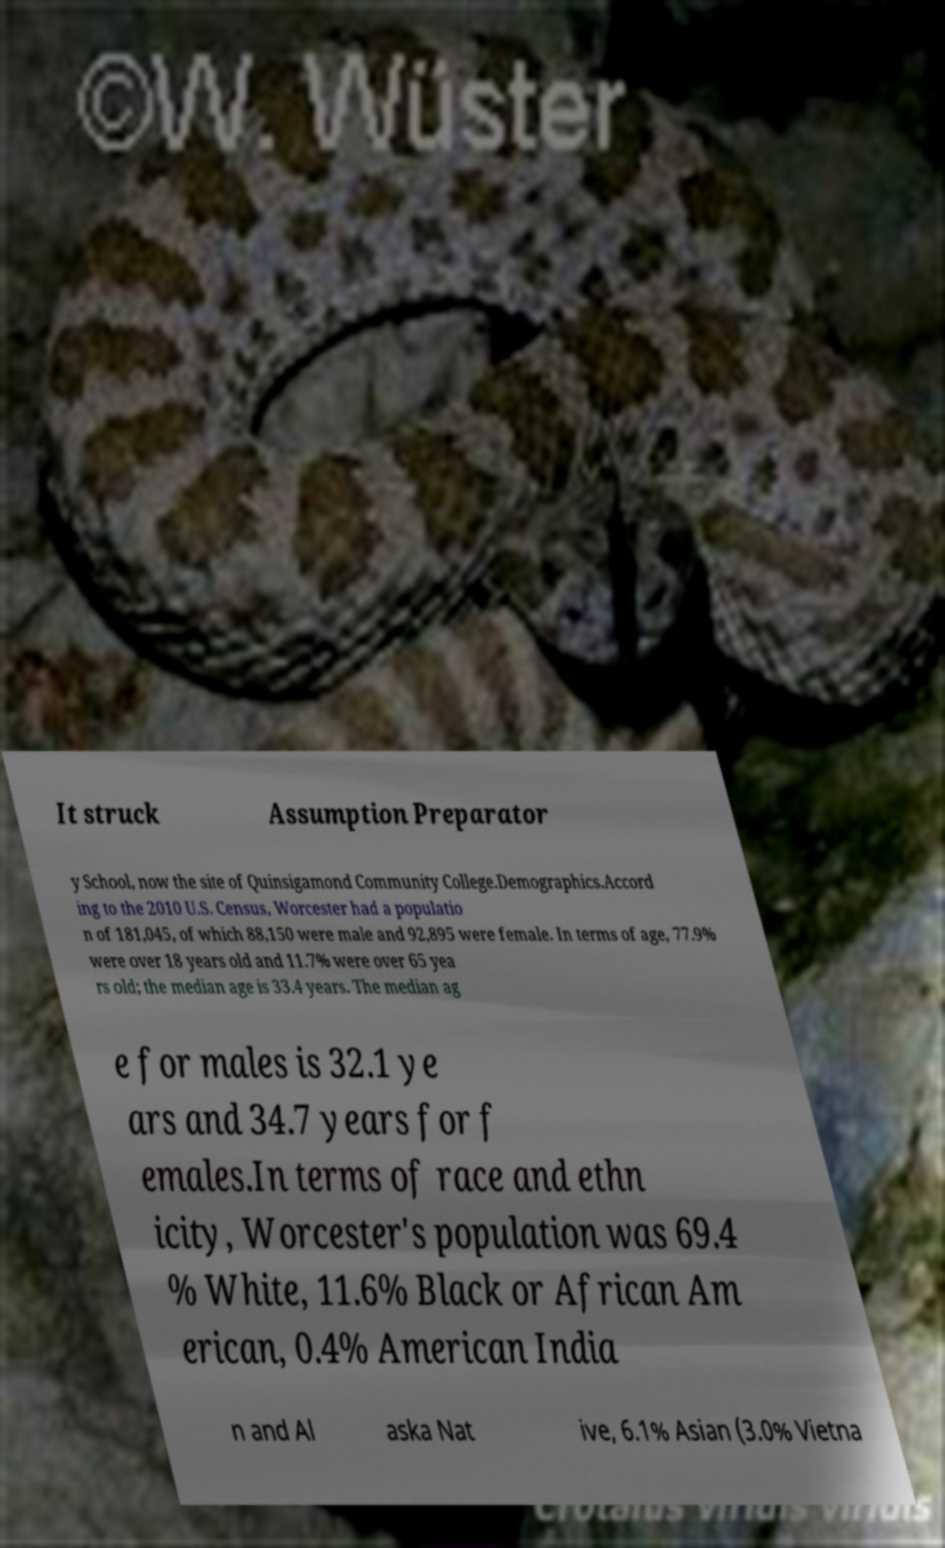Could you assist in decoding the text presented in this image and type it out clearly? It struck Assumption Preparator y School, now the site of Quinsigamond Community College.Demographics.Accord ing to the 2010 U.S. Census, Worcester had a populatio n of 181,045, of which 88,150 were male and 92,895 were female. In terms of age, 77.9% were over 18 years old and 11.7% were over 65 yea rs old; the median age is 33.4 years. The median ag e for males is 32.1 ye ars and 34.7 years for f emales.In terms of race and ethn icity, Worcester's population was 69.4 % White, 11.6% Black or African Am erican, 0.4% American India n and Al aska Nat ive, 6.1% Asian (3.0% Vietna 